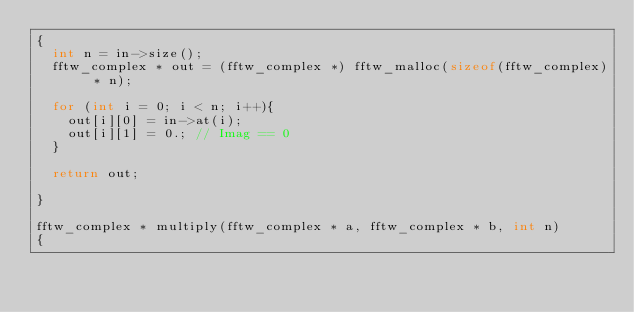Convert code to text. <code><loc_0><loc_0><loc_500><loc_500><_C++_>{
  int n = in->size();
  fftw_complex * out = (fftw_complex *) fftw_malloc(sizeof(fftw_complex) * n);

  for (int i = 0; i < n; i++){
    out[i][0] = in->at(i);
    out[i][1] = 0.; // Imag == 0
  }

  return out;

}

fftw_complex * multiply(fftw_complex * a, fftw_complex * b, int n)
{</code> 